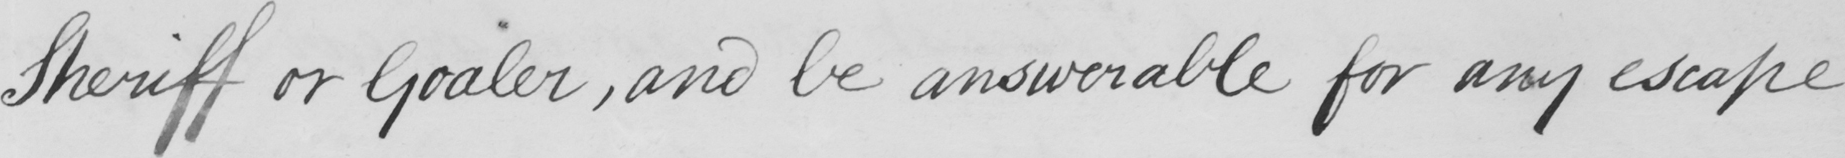Please transcribe the handwritten text in this image. Sheriff or Goaler , and be answerable for any escape 